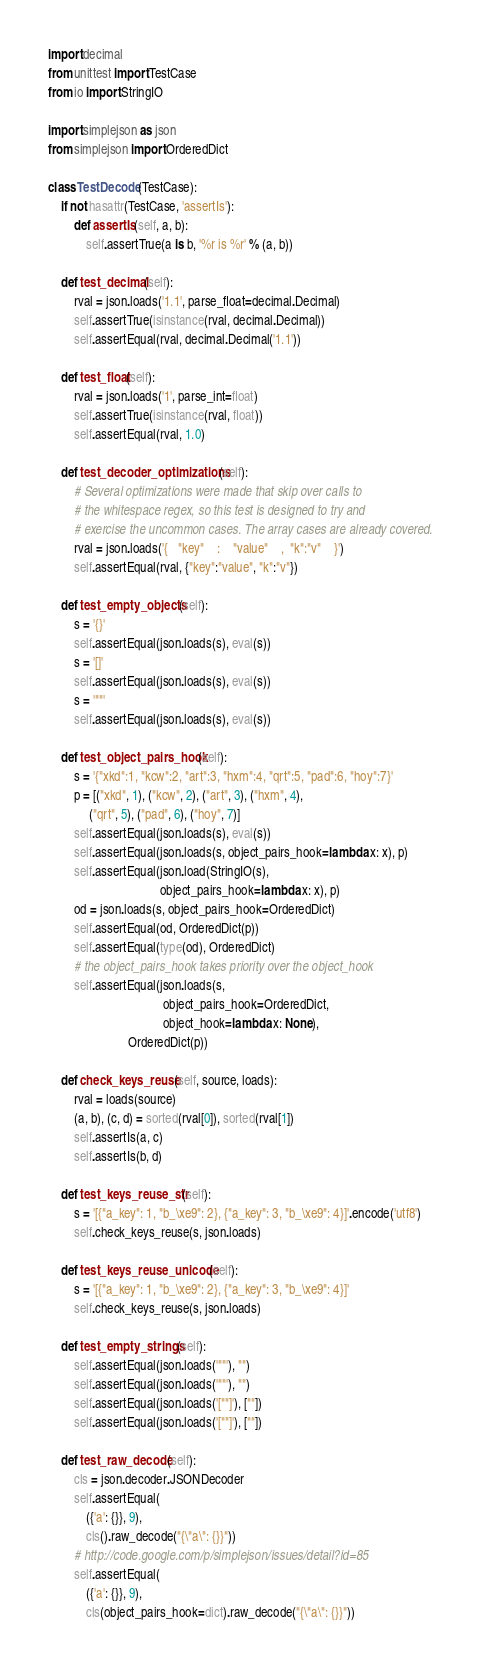Convert code to text. <code><loc_0><loc_0><loc_500><loc_500><_Python_>import decimal
from unittest import TestCase
from io import StringIO

import simplejson as json
from simplejson import OrderedDict

class TestDecode(TestCase):
    if not hasattr(TestCase, 'assertIs'):
        def assertIs(self, a, b):
            self.assertTrue(a is b, '%r is %r' % (a, b))

    def test_decimal(self):
        rval = json.loads('1.1', parse_float=decimal.Decimal)
        self.assertTrue(isinstance(rval, decimal.Decimal))
        self.assertEqual(rval, decimal.Decimal('1.1'))

    def test_float(self):
        rval = json.loads('1', parse_int=float)
        self.assertTrue(isinstance(rval, float))
        self.assertEqual(rval, 1.0)

    def test_decoder_optimizations(self):
        # Several optimizations were made that skip over calls to
        # the whitespace regex, so this test is designed to try and
        # exercise the uncommon cases. The array cases are already covered.
        rval = json.loads('{   "key"    :    "value"    ,  "k":"v"    }')
        self.assertEqual(rval, {"key":"value", "k":"v"})

    def test_empty_objects(self):
        s = '{}'
        self.assertEqual(json.loads(s), eval(s))
        s = '[]'
        self.assertEqual(json.loads(s), eval(s))
        s = '""'
        self.assertEqual(json.loads(s), eval(s))

    def test_object_pairs_hook(self):
        s = '{"xkd":1, "kcw":2, "art":3, "hxm":4, "qrt":5, "pad":6, "hoy":7}'
        p = [("xkd", 1), ("kcw", 2), ("art", 3), ("hxm", 4),
             ("qrt", 5), ("pad", 6), ("hoy", 7)]
        self.assertEqual(json.loads(s), eval(s))
        self.assertEqual(json.loads(s, object_pairs_hook=lambda x: x), p)
        self.assertEqual(json.load(StringIO(s),
                                   object_pairs_hook=lambda x: x), p)
        od = json.loads(s, object_pairs_hook=OrderedDict)
        self.assertEqual(od, OrderedDict(p))
        self.assertEqual(type(od), OrderedDict)
        # the object_pairs_hook takes priority over the object_hook
        self.assertEqual(json.loads(s,
                                    object_pairs_hook=OrderedDict,
                                    object_hook=lambda x: None),
                         OrderedDict(p))

    def check_keys_reuse(self, source, loads):
        rval = loads(source)
        (a, b), (c, d) = sorted(rval[0]), sorted(rval[1])
        self.assertIs(a, c)
        self.assertIs(b, d)

    def test_keys_reuse_str(self):
        s = '[{"a_key": 1, "b_\xe9": 2}, {"a_key": 3, "b_\xe9": 4}]'.encode('utf8')
        self.check_keys_reuse(s, json.loads)

    def test_keys_reuse_unicode(self):
        s = '[{"a_key": 1, "b_\xe9": 2}, {"a_key": 3, "b_\xe9": 4}]'
        self.check_keys_reuse(s, json.loads)

    def test_empty_strings(self):
        self.assertEqual(json.loads('""'), "")
        self.assertEqual(json.loads('""'), "")
        self.assertEqual(json.loads('[""]'), [""])
        self.assertEqual(json.loads('[""]'), [""])

    def test_raw_decode(self):
        cls = json.decoder.JSONDecoder
        self.assertEqual(
            ({'a': {}}, 9),
            cls().raw_decode("{\"a\": {}}"))
        # http://code.google.com/p/simplejson/issues/detail?id=85
        self.assertEqual(
            ({'a': {}}, 9),
            cls(object_pairs_hook=dict).raw_decode("{\"a\": {}}"))
</code> 